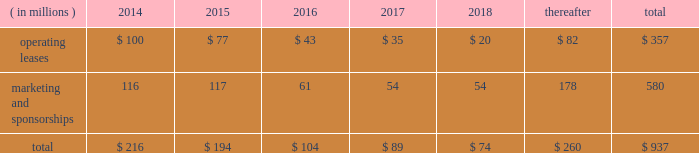Visa inc .
Notes to consolidated financial statements 2014 ( continued ) september 30 , 2013 market condition is based on the company 2019s total shareholder return ranked against that of other companies that are included in the standard & poor 2019s 500 index .
The fair value of the performance- based shares , incorporating the market condition , is estimated on the grant date using a monte carlo simulation model .
The grant-date fair value of performance-based shares in fiscal 2013 , 2012 and 2011 was $ 164.14 , $ 97.84 and $ 85.05 per share , respectively .
Earned performance shares granted in fiscal 2013 and 2012 vest approximately three years from the initial grant date .
Earned performance shares granted in fiscal 2011 vest in two equal installments approximately two and three years from their respective grant dates .
All performance awards are subject to earlier vesting in full under certain conditions .
Compensation cost for performance-based shares is initially estimated based on target performance .
It is recorded net of estimated forfeitures and adjusted as appropriate throughout the performance period .
At september 30 , 2013 , there was $ 15 million of total unrecognized compensation cost related to unvested performance-based shares , which is expected to be recognized over a weighted-average period of approximately 1.0 years .
Note 17 2014commitments and contingencies commitments .
The company leases certain premises and equipment throughout the world with varying expiration dates .
The company incurred total rent expense of $ 94 million , $ 89 million and $ 76 million in fiscal 2013 , 2012 and 2011 , respectively .
Future minimum payments on leases , and marketing and sponsorship agreements per fiscal year , at september 30 , 2013 , are as follows: .
Select sponsorship agreements require the company to spend certain minimum amounts for advertising and marketing promotion over the life of the contract .
For commitments where the individual years of spend are not specified in the contract , the company has estimated the timing of when these amounts will be spent .
In addition to the fixed payments stated above , select sponsorship agreements require the company to undertake marketing , promotional or other activities up to stated monetary values to support events which the company is sponsoring .
The stated monetary value of these activities typically represents the value in the marketplace , which may be significantly in excess of the actual costs incurred by the company .
Client incentives .
The company has agreements with financial institution clients and other business partners for various programs designed to build payments volume , increase visa-branded card and product acceptance and win merchant routing transactions .
These agreements , with original terms ranging from one to thirteen years , can provide card issuance and/or conversion support , volume/growth targets and marketing and program support based on specific performance requirements .
These agreements are designed to encourage client business and to increase overall visa-branded payment and transaction volume , thereby reducing per-unit transaction processing costs and increasing brand awareness for all visa clients .
Payments made that qualify for capitalization , and obligations incurred under these programs are reflected on the consolidated balance sheet .
Client incentives are recognized primarily as a reduction .
What was the average rent expense from 2011 to 2013 in millions? 
Computations: (((76 + (94 + 89)) + 3) / 2)
Answer: 131.0. 